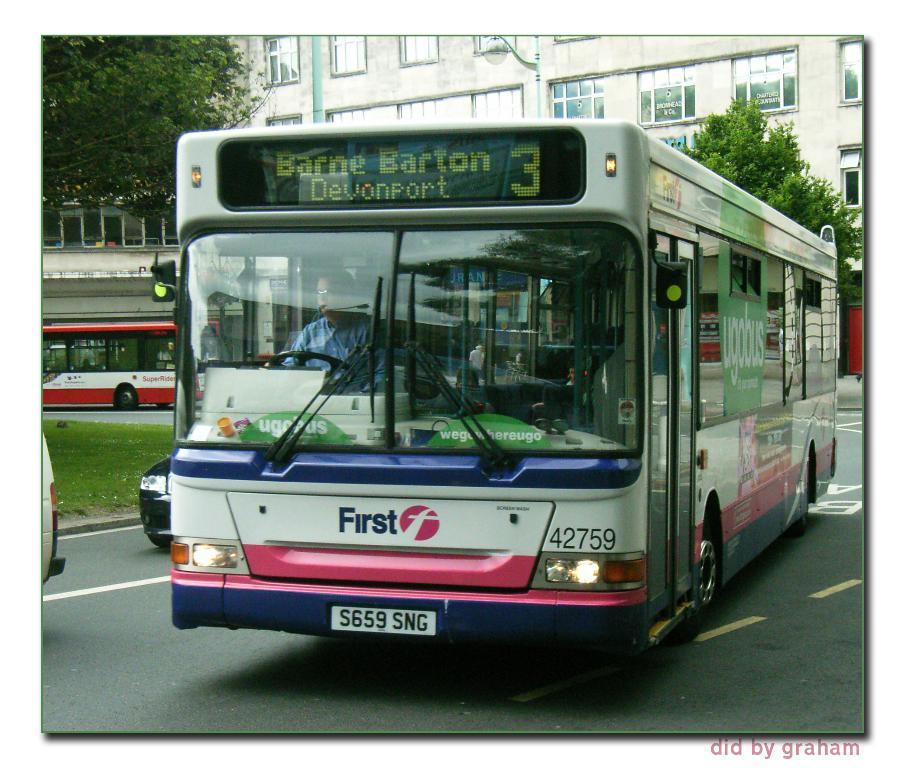Could you give a brief overview of what you see in this image? This image is clicked outside. There is a building at the top. There are buses in the middle. There is grass on the left side. There are trees on the left side and right side. 